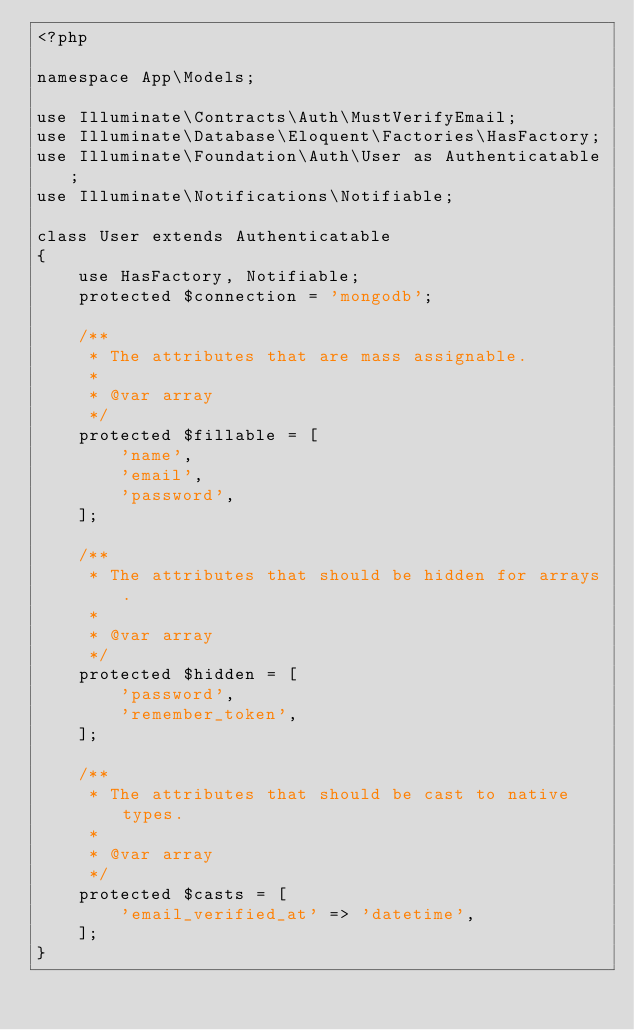<code> <loc_0><loc_0><loc_500><loc_500><_PHP_><?php

namespace App\Models;

use Illuminate\Contracts\Auth\MustVerifyEmail;
use Illuminate\Database\Eloquent\Factories\HasFactory;
use Illuminate\Foundation\Auth\User as Authenticatable;
use Illuminate\Notifications\Notifiable;

class User extends Authenticatable
{
    use HasFactory, Notifiable;
    protected $connection = 'mongodb';

    /**
     * The attributes that are mass assignable.
     *
     * @var array
     */
    protected $fillable = [
        'name',
        'email',
        'password',
    ];

    /**
     * The attributes that should be hidden for arrays.
     *
     * @var array
     */
    protected $hidden = [
        'password',
        'remember_token',
    ];

    /**
     * The attributes that should be cast to native types.
     *
     * @var array
     */
    protected $casts = [
        'email_verified_at' => 'datetime',
    ];
}
</code> 